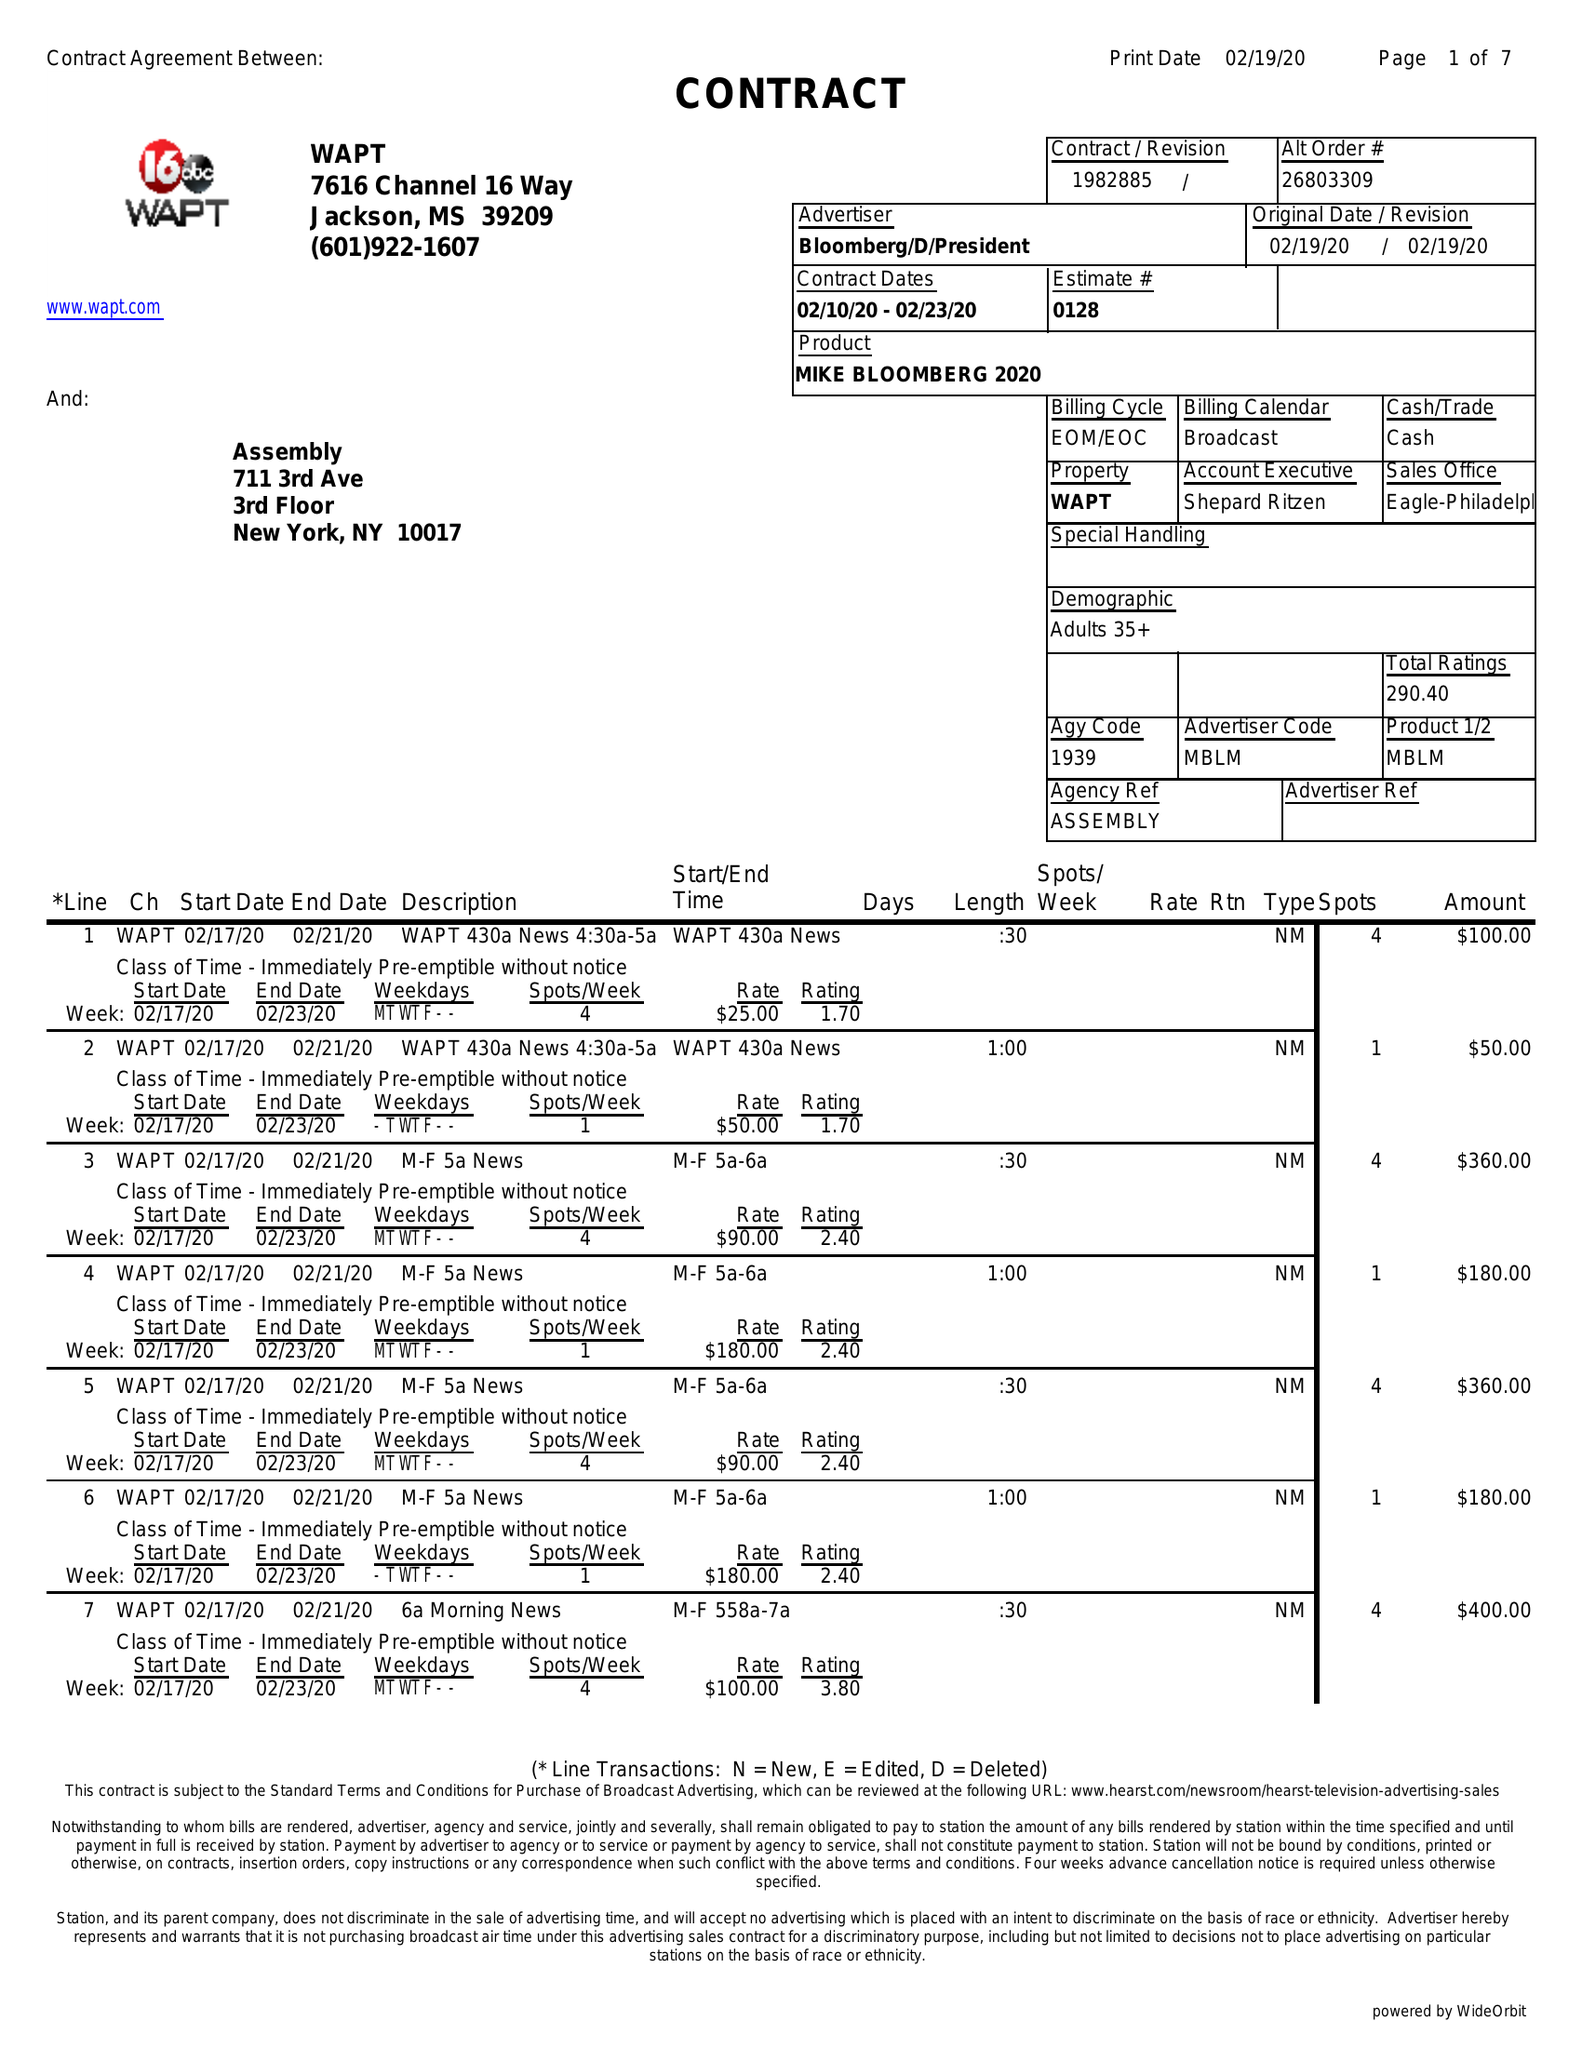What is the value for the gross_amount?
Answer the question using a single word or phrase. 11480.00 